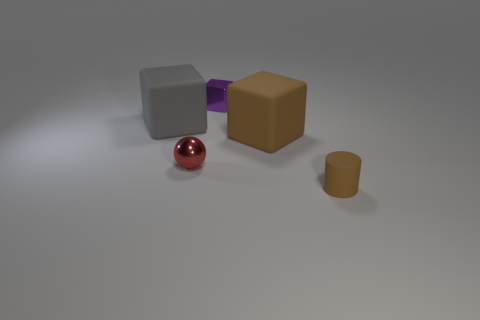Add 2 rubber objects. How many objects exist? 7 Subtract all blocks. How many objects are left? 2 Subtract all tiny brown rubber things. Subtract all spheres. How many objects are left? 3 Add 5 small purple things. How many small purple things are left? 6 Add 1 large cyan rubber things. How many large cyan rubber things exist? 1 Subtract 0 yellow balls. How many objects are left? 5 